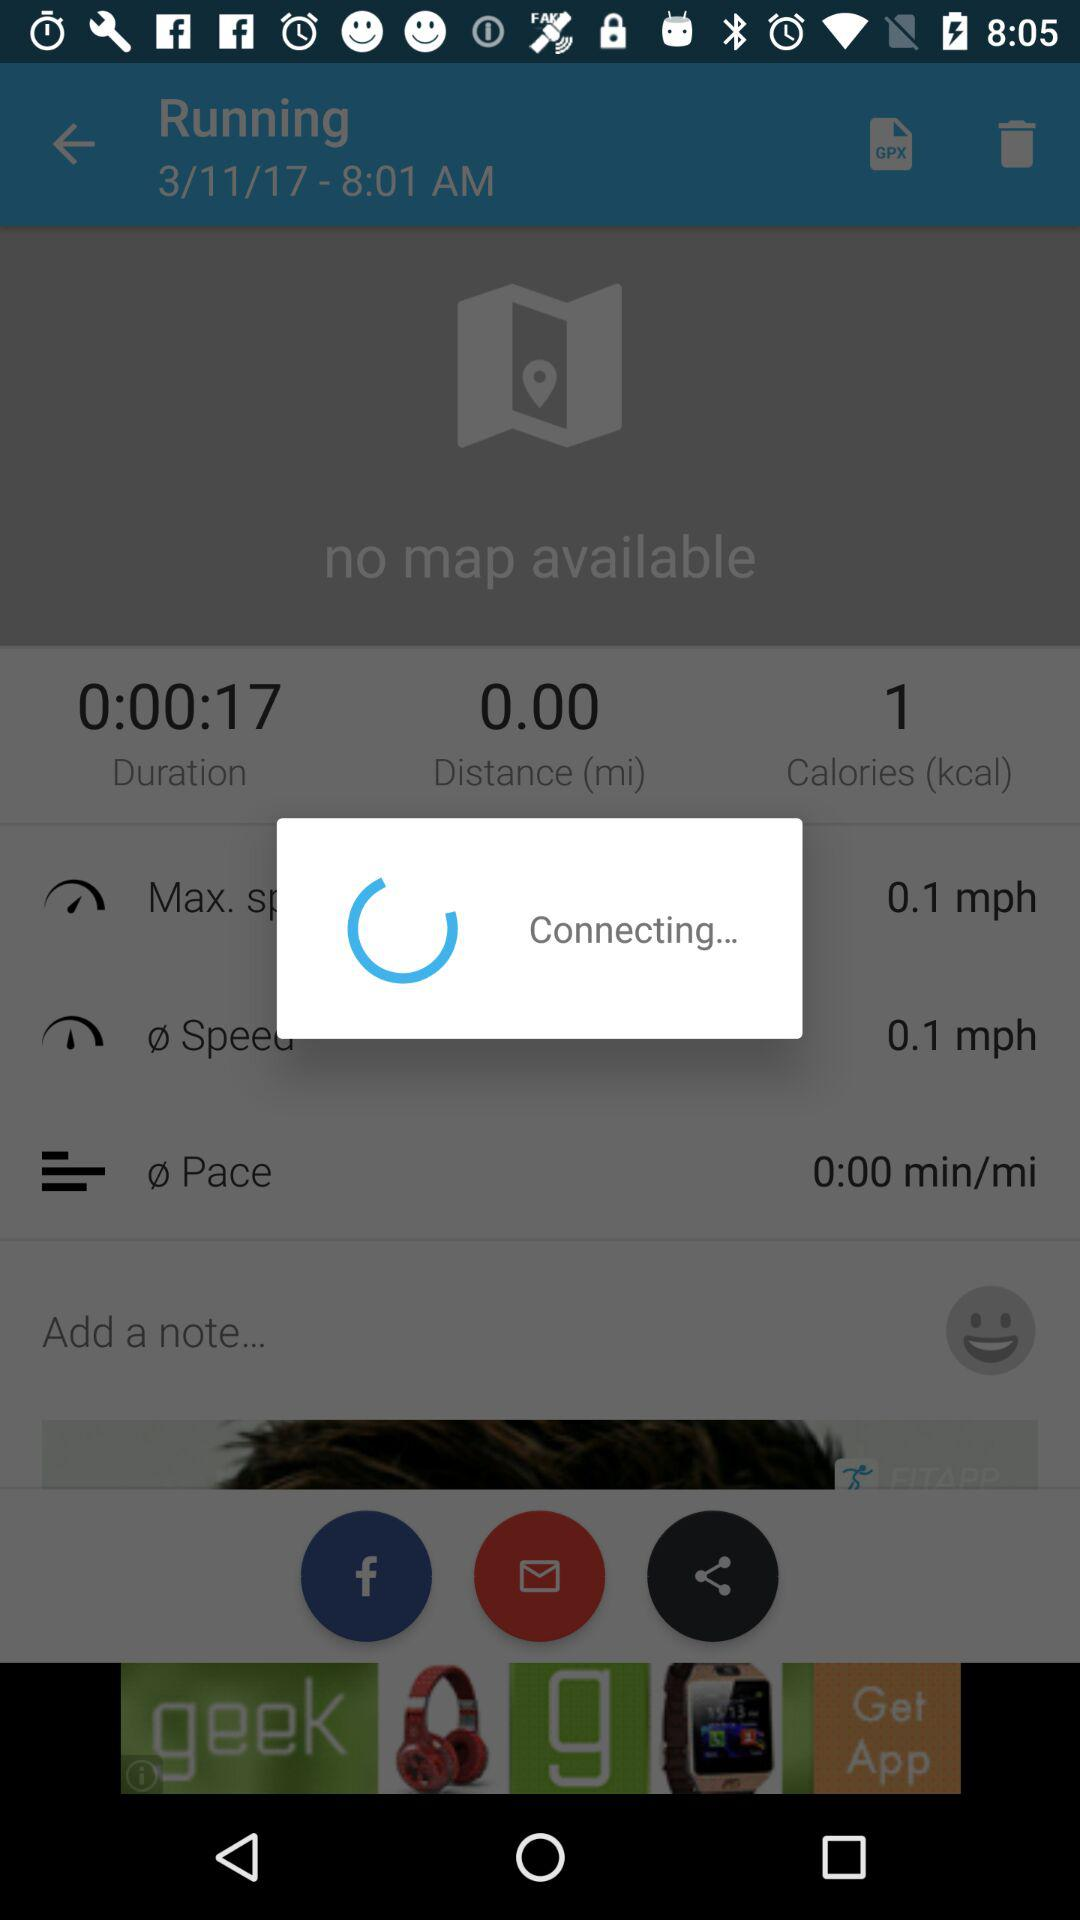What is the distance? The distance is 0.00 miles. 